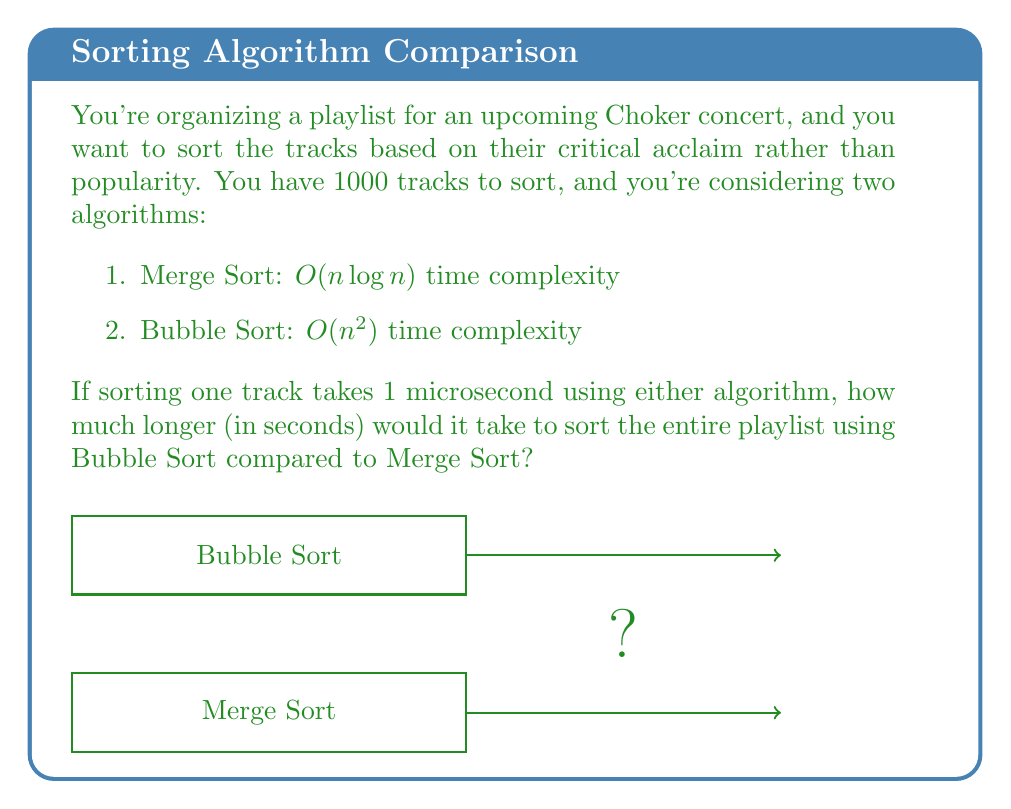Can you solve this math problem? Let's approach this step-by-step:

1) First, let's calculate the time for Merge Sort:
   - Time complexity: $O(n \log n)$
   - $n = 1000$
   - Time = $1000 \log 1000$ microseconds
   - $\log 1000 \approx 9.97$
   - Time ≈ $9970$ microseconds

2) Now, let's calculate the time for Bubble Sort:
   - Time complexity: $O(n^2)$
   - $n = 1000$
   - Time = $1000^2$ microseconds
   - Time = $1,000,000$ microseconds

3) To find the difference:
   $1,000,000 - 9970 = 990,030$ microseconds

4) Convert to seconds:
   $990,030$ microseconds = $990,030 / 1,000,000 = 0.99003$ seconds

Therefore, Bubble Sort would take approximately 0.99003 seconds longer than Merge Sort to sort the playlist.
Answer: 0.99003 seconds 